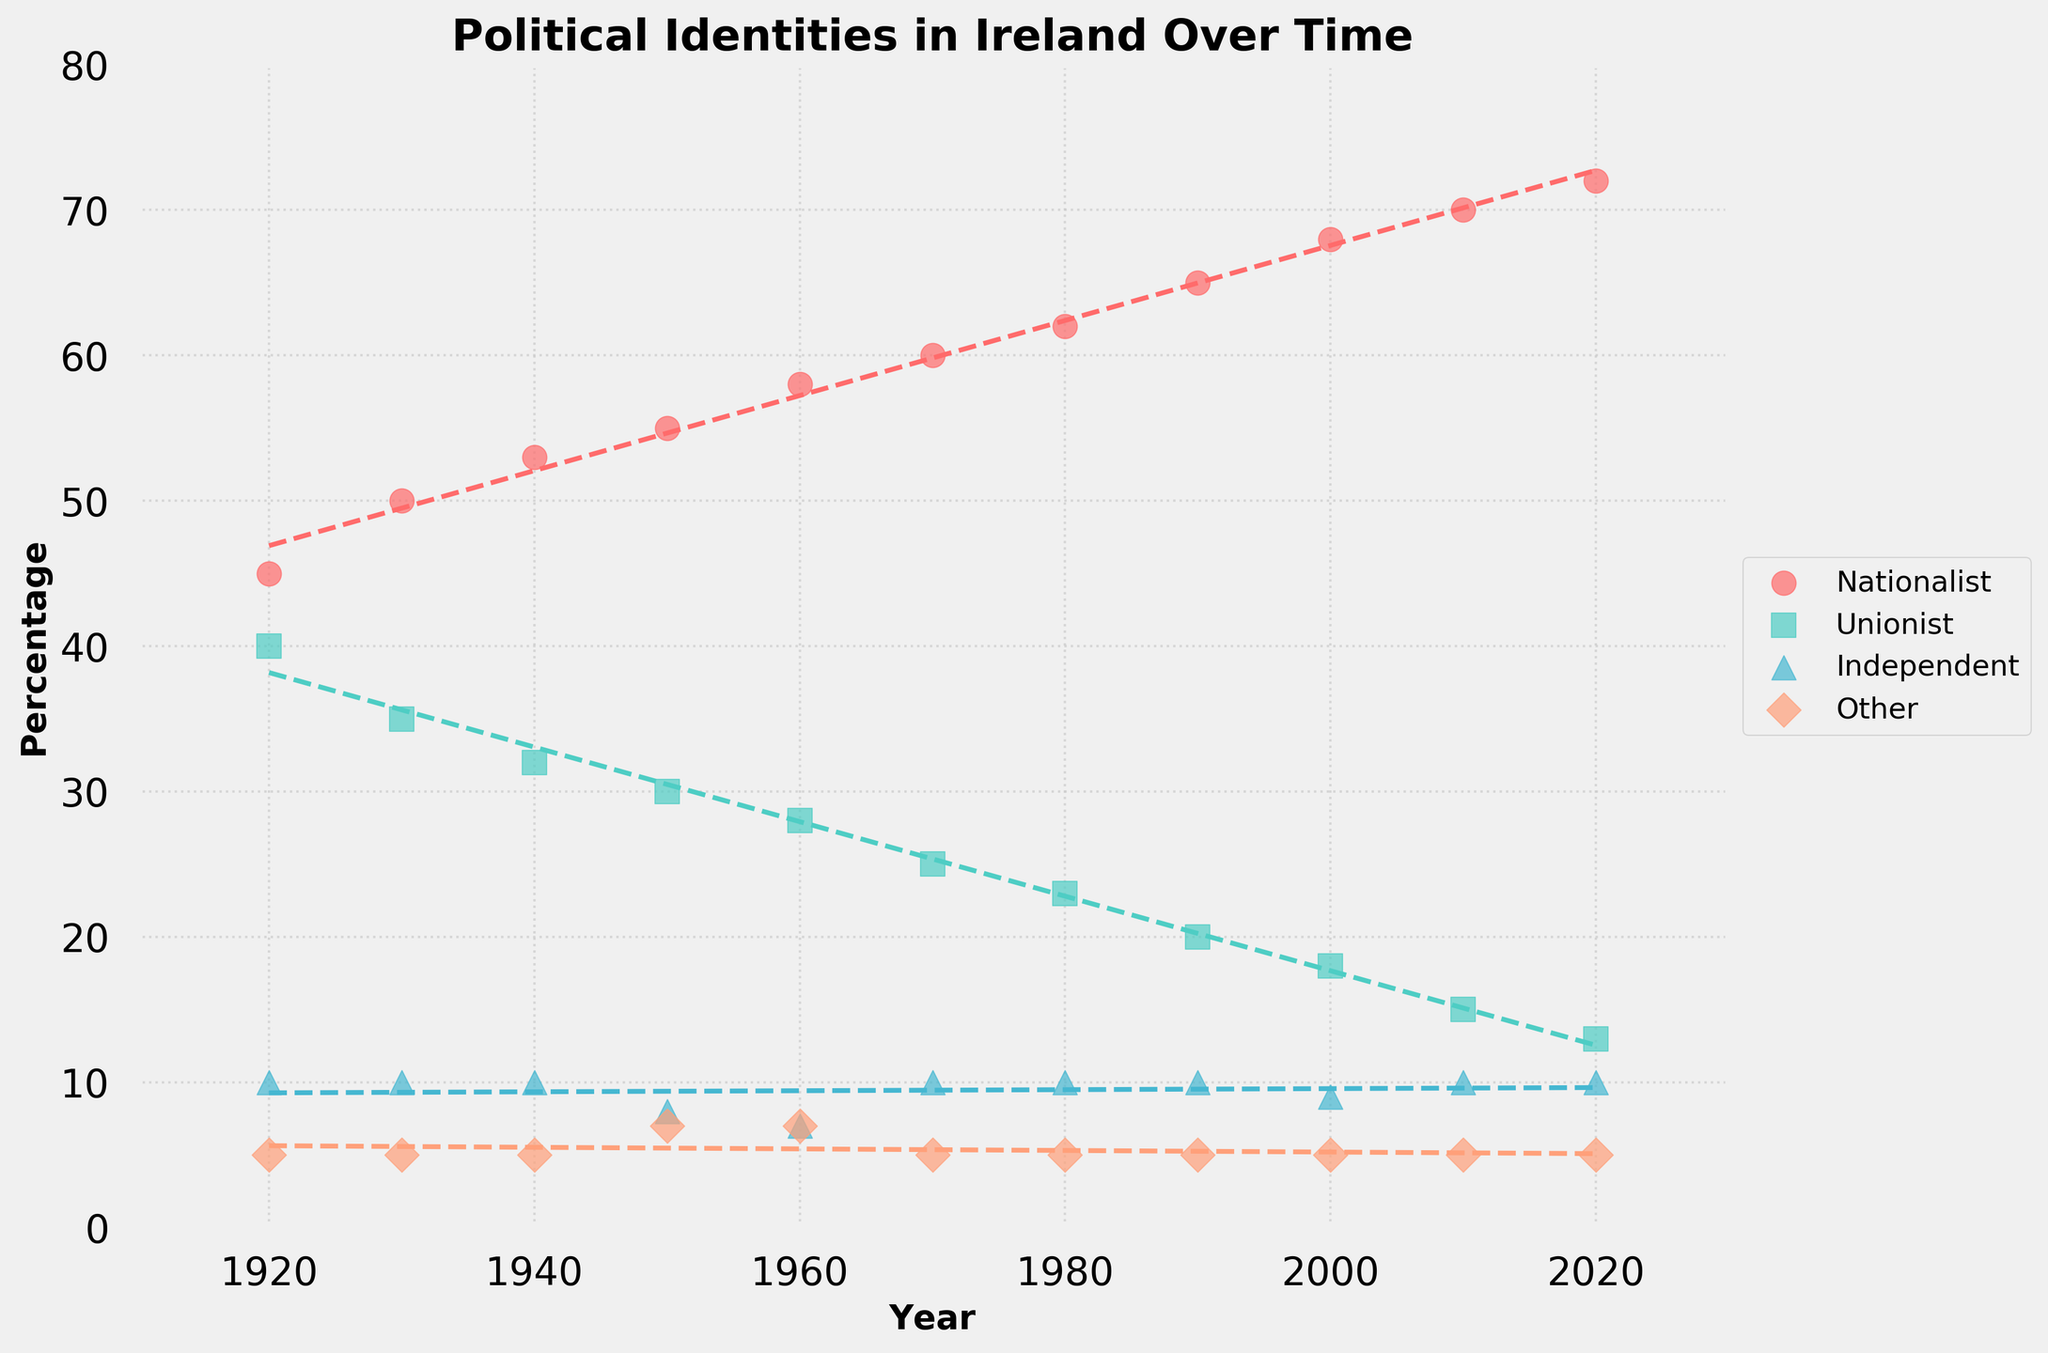What is the title of the figure? The title is located at the top of the figure and summarizes the main subject of the plot, in bold text.
Answer: Political Identities in Ireland Over Time What does the x-axis represent? The x-axis label near the bottom of the plot indicates the variable represented along this axis, written with a bold font.
Answer: Year Which political identity had the highest percentage in 1940? Look at the data points for the year 1940 and identify the highest value among the different political identities.
Answer: Nationalist By how much did the percentage of people identifying as Unionist change from 1920 to 2020? Subtract the value in 2020 from the value in 1920 for the Unionist category.
Answer: 27% Which political identity shows the most significant upward trend over time? Identify which trend line has the steepest positive slope, representing the highest increase over the years.
Answer: Nationalist Which year had the lowest percentage for the Independent political identity? Look at the scatter points for Independent and identify the year with the lowest value.
Answer: 1960 Compare the percentage trends for Nationalist and Unionist from 1920 to 2020. What do you observe? Observe the direction and slope of the trend lines for both categories and compare their overall patterns over time.
Answer: Nationalist shows a steady increase, while Unionist shows a steady decrease What is the average percentage for the Other political identity from 1920 to 2020? Sum all percentages for "Other" and divide by the number of data points.
Answer: 5.36% Which political identities have relatively stable percentages over the years? Look for the identities whose trend lines have the least changes in slope, indicating stability.
Answer: Independent and Other In what year did Nationalist and Unionist percentages have the closest values, and what were those values? Identify the year where the difference between Nationalist and Unionist percentages is the smallest by comparing values year by year.
Answer: 1920, 45% and 40% 